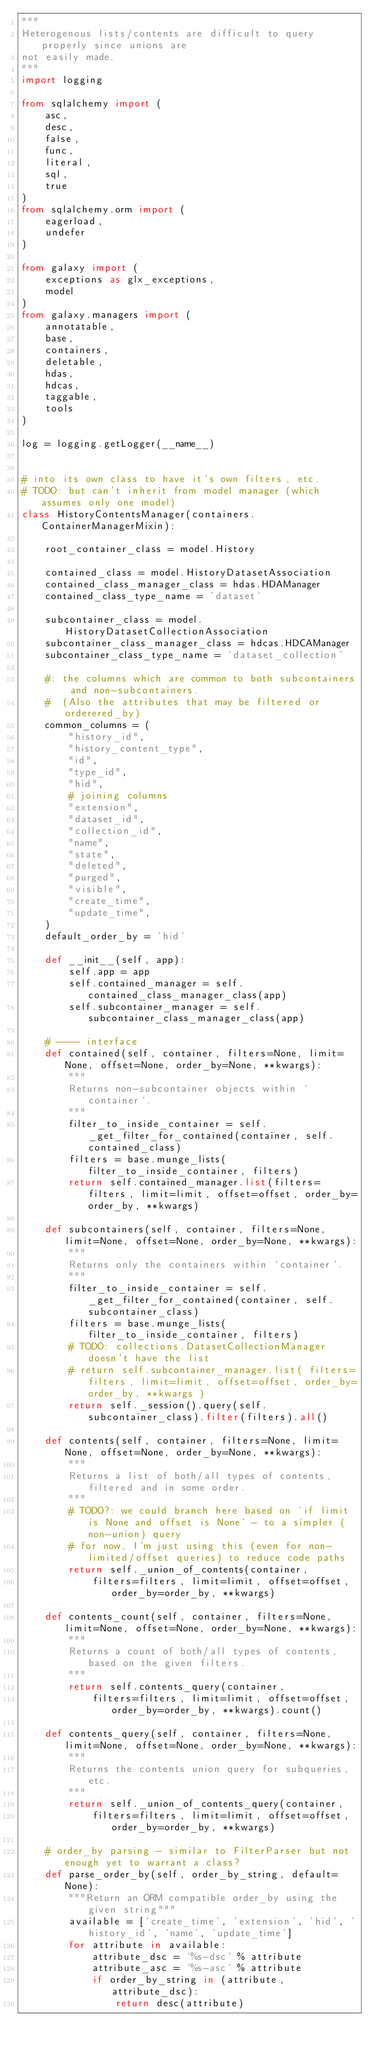<code> <loc_0><loc_0><loc_500><loc_500><_Python_>"""
Heterogenous lists/contents are difficult to query properly since unions are
not easily made.
"""
import logging

from sqlalchemy import (
    asc,
    desc,
    false,
    func,
    literal,
    sql,
    true
)
from sqlalchemy.orm import (
    eagerload,
    undefer
)

from galaxy import (
    exceptions as glx_exceptions,
    model
)
from galaxy.managers import (
    annotatable,
    base,
    containers,
    deletable,
    hdas,
    hdcas,
    taggable,
    tools
)

log = logging.getLogger(__name__)


# into its own class to have it's own filters, etc.
# TODO: but can't inherit from model manager (which assumes only one model)
class HistoryContentsManager(containers.ContainerManagerMixin):

    root_container_class = model.History

    contained_class = model.HistoryDatasetAssociation
    contained_class_manager_class = hdas.HDAManager
    contained_class_type_name = 'dataset'

    subcontainer_class = model.HistoryDatasetCollectionAssociation
    subcontainer_class_manager_class = hdcas.HDCAManager
    subcontainer_class_type_name = 'dataset_collection'

    #: the columns which are common to both subcontainers and non-subcontainers.
    #  (Also the attributes that may be filtered or orderered_by)
    common_columns = (
        "history_id",
        "history_content_type",
        "id",
        "type_id",
        "hid",
        # joining columns
        "extension",
        "dataset_id",
        "collection_id",
        "name",
        "state",
        "deleted",
        "purged",
        "visible",
        "create_time",
        "update_time",
    )
    default_order_by = 'hid'

    def __init__(self, app):
        self.app = app
        self.contained_manager = self.contained_class_manager_class(app)
        self.subcontainer_manager = self.subcontainer_class_manager_class(app)

    # ---- interface
    def contained(self, container, filters=None, limit=None, offset=None, order_by=None, **kwargs):
        """
        Returns non-subcontainer objects within `container`.
        """
        filter_to_inside_container = self._get_filter_for_contained(container, self.contained_class)
        filters = base.munge_lists(filter_to_inside_container, filters)
        return self.contained_manager.list(filters=filters, limit=limit, offset=offset, order_by=order_by, **kwargs)

    def subcontainers(self, container, filters=None, limit=None, offset=None, order_by=None, **kwargs):
        """
        Returns only the containers within `container`.
        """
        filter_to_inside_container = self._get_filter_for_contained(container, self.subcontainer_class)
        filters = base.munge_lists(filter_to_inside_container, filters)
        # TODO: collections.DatasetCollectionManager doesn't have the list
        # return self.subcontainer_manager.list( filters=filters, limit=limit, offset=offset, order_by=order_by, **kwargs )
        return self._session().query(self.subcontainer_class).filter(filters).all()

    def contents(self, container, filters=None, limit=None, offset=None, order_by=None, **kwargs):
        """
        Returns a list of both/all types of contents, filtered and in some order.
        """
        # TODO?: we could branch here based on 'if limit is None and offset is None' - to a simpler (non-union) query
        # for now, I'm just using this (even for non-limited/offset queries) to reduce code paths
        return self._union_of_contents(container,
            filters=filters, limit=limit, offset=offset, order_by=order_by, **kwargs)

    def contents_count(self, container, filters=None, limit=None, offset=None, order_by=None, **kwargs):
        """
        Returns a count of both/all types of contents, based on the given filters.
        """
        return self.contents_query(container,
            filters=filters, limit=limit, offset=offset, order_by=order_by, **kwargs).count()

    def contents_query(self, container, filters=None, limit=None, offset=None, order_by=None, **kwargs):
        """
        Returns the contents union query for subqueries, etc.
        """
        return self._union_of_contents_query(container,
            filters=filters, limit=limit, offset=offset, order_by=order_by, **kwargs)

    # order_by parsing - similar to FilterParser but not enough yet to warrant a class?
    def parse_order_by(self, order_by_string, default=None):
        """Return an ORM compatible order_by using the given string"""
        available = ['create_time', 'extension', 'hid', 'history_id', 'name', 'update_time']
        for attribute in available:
            attribute_dsc = '%s-dsc' % attribute
            attribute_asc = '%s-asc' % attribute
            if order_by_string in (attribute, attribute_dsc):
                return desc(attribute)</code> 